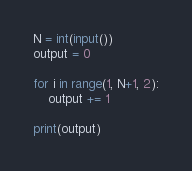<code> <loc_0><loc_0><loc_500><loc_500><_Python_>N = int(input())
output = 0

for i in range(1, N+1, 2):
    output += 1

print(output)
</code> 